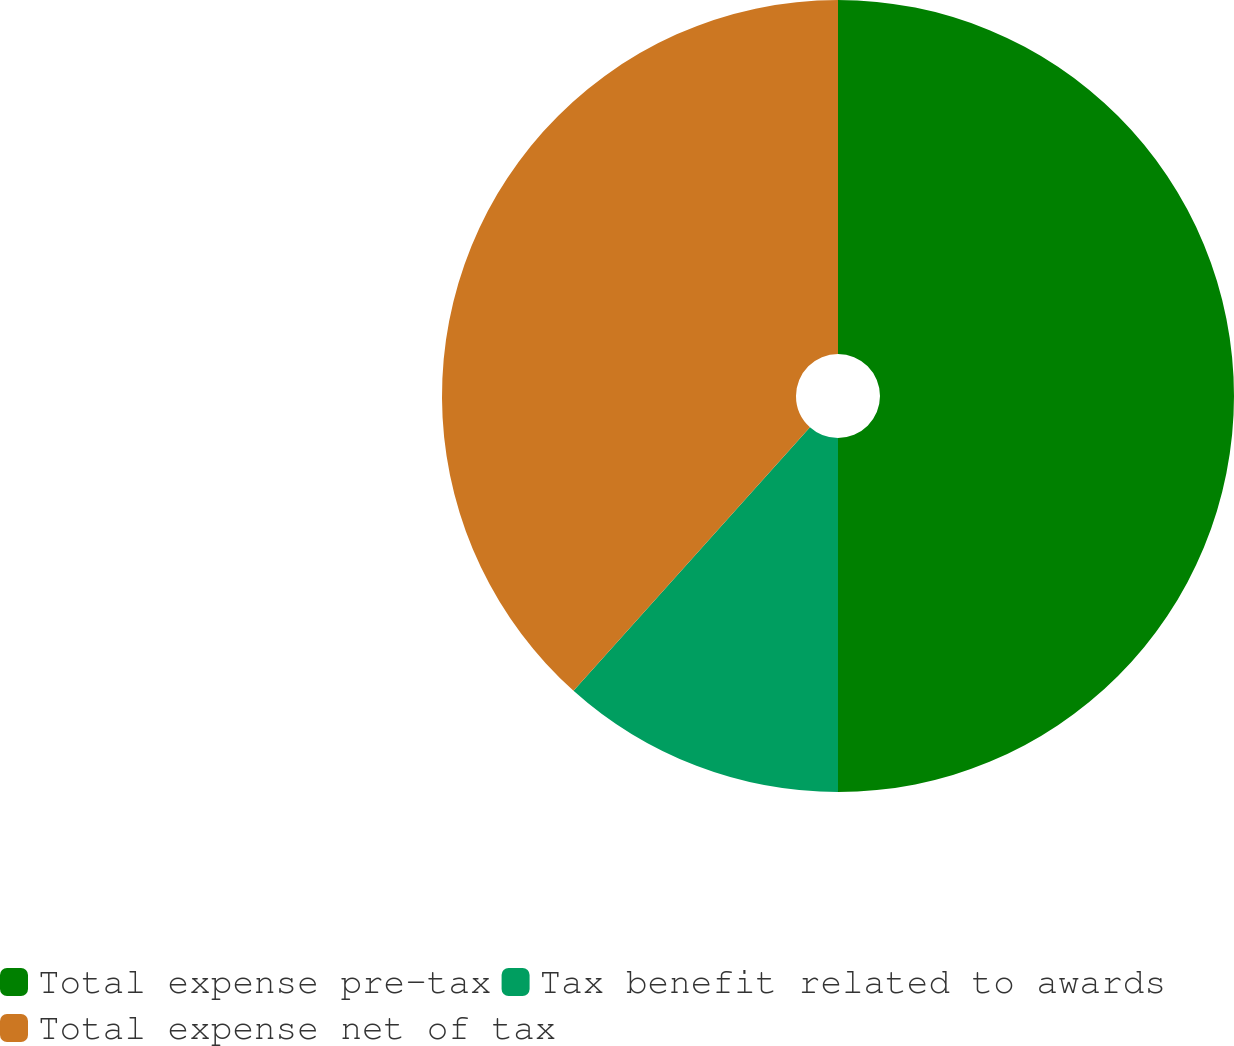<chart> <loc_0><loc_0><loc_500><loc_500><pie_chart><fcel>Total expense pre-tax<fcel>Tax benefit related to awards<fcel>Total expense net of tax<nl><fcel>50.0%<fcel>11.64%<fcel>38.36%<nl></chart> 